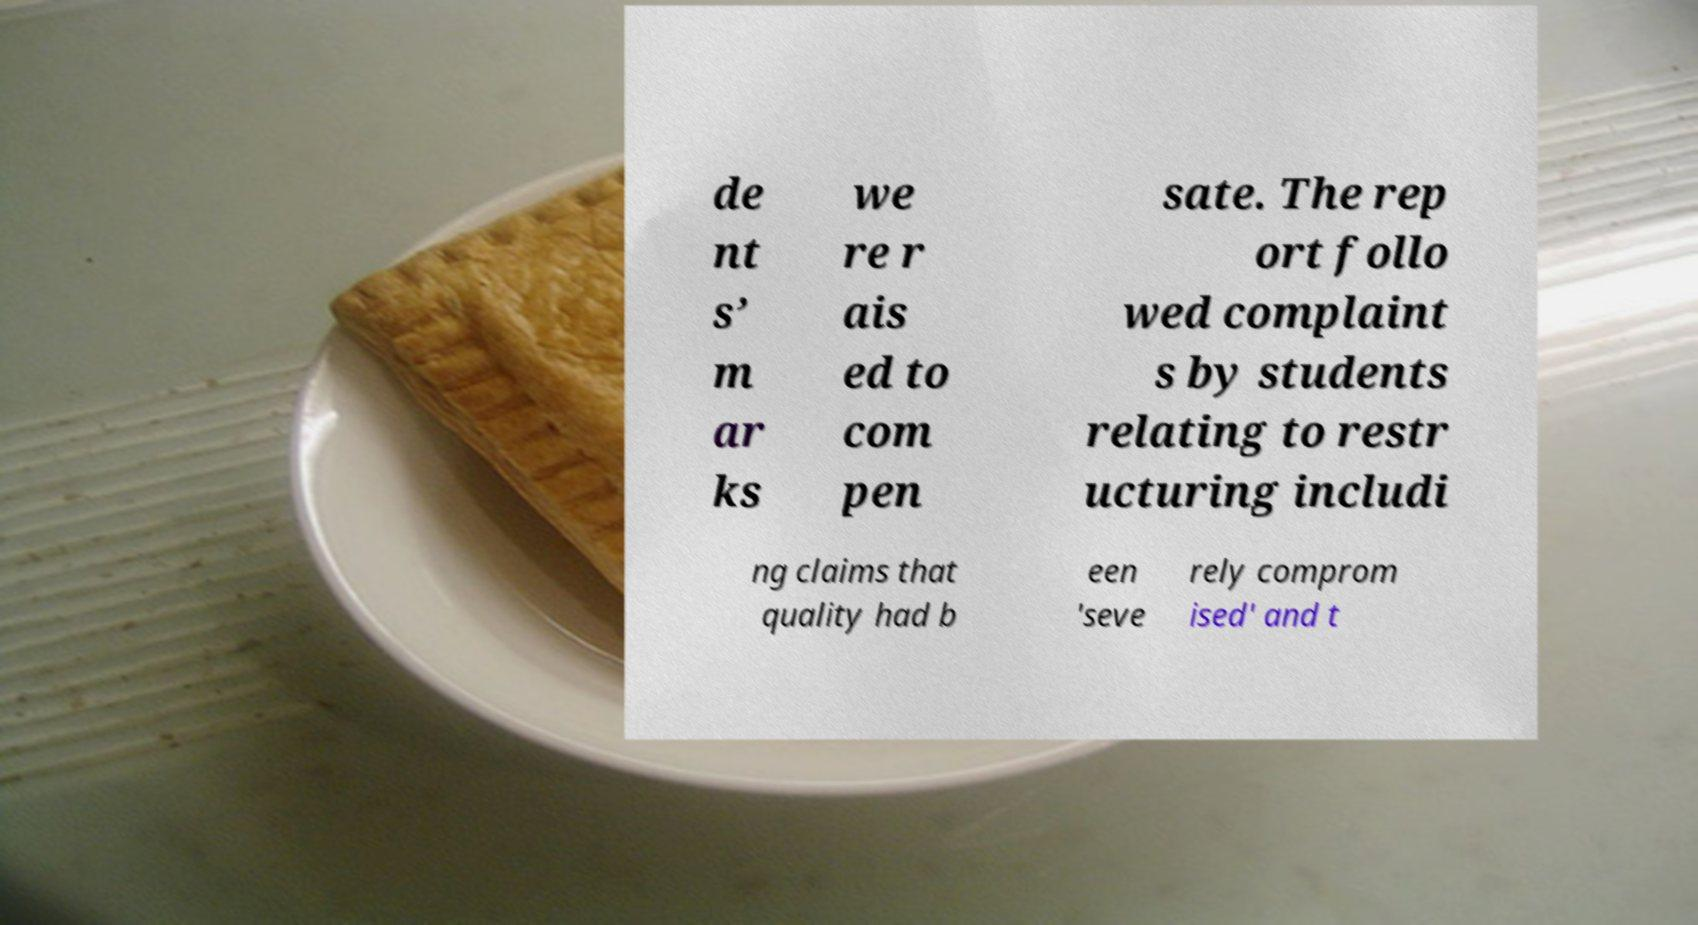Please read and relay the text visible in this image. What does it say? de nt s’ m ar ks we re r ais ed to com pen sate. The rep ort follo wed complaint s by students relating to restr ucturing includi ng claims that quality had b een 'seve rely comprom ised' and t 